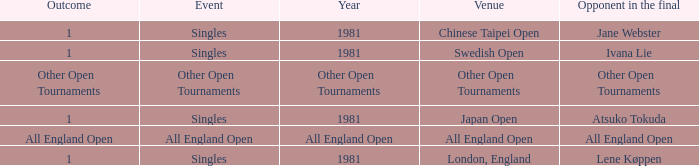What Event has an Outcome of other open tournaments? Other Open Tournaments. 